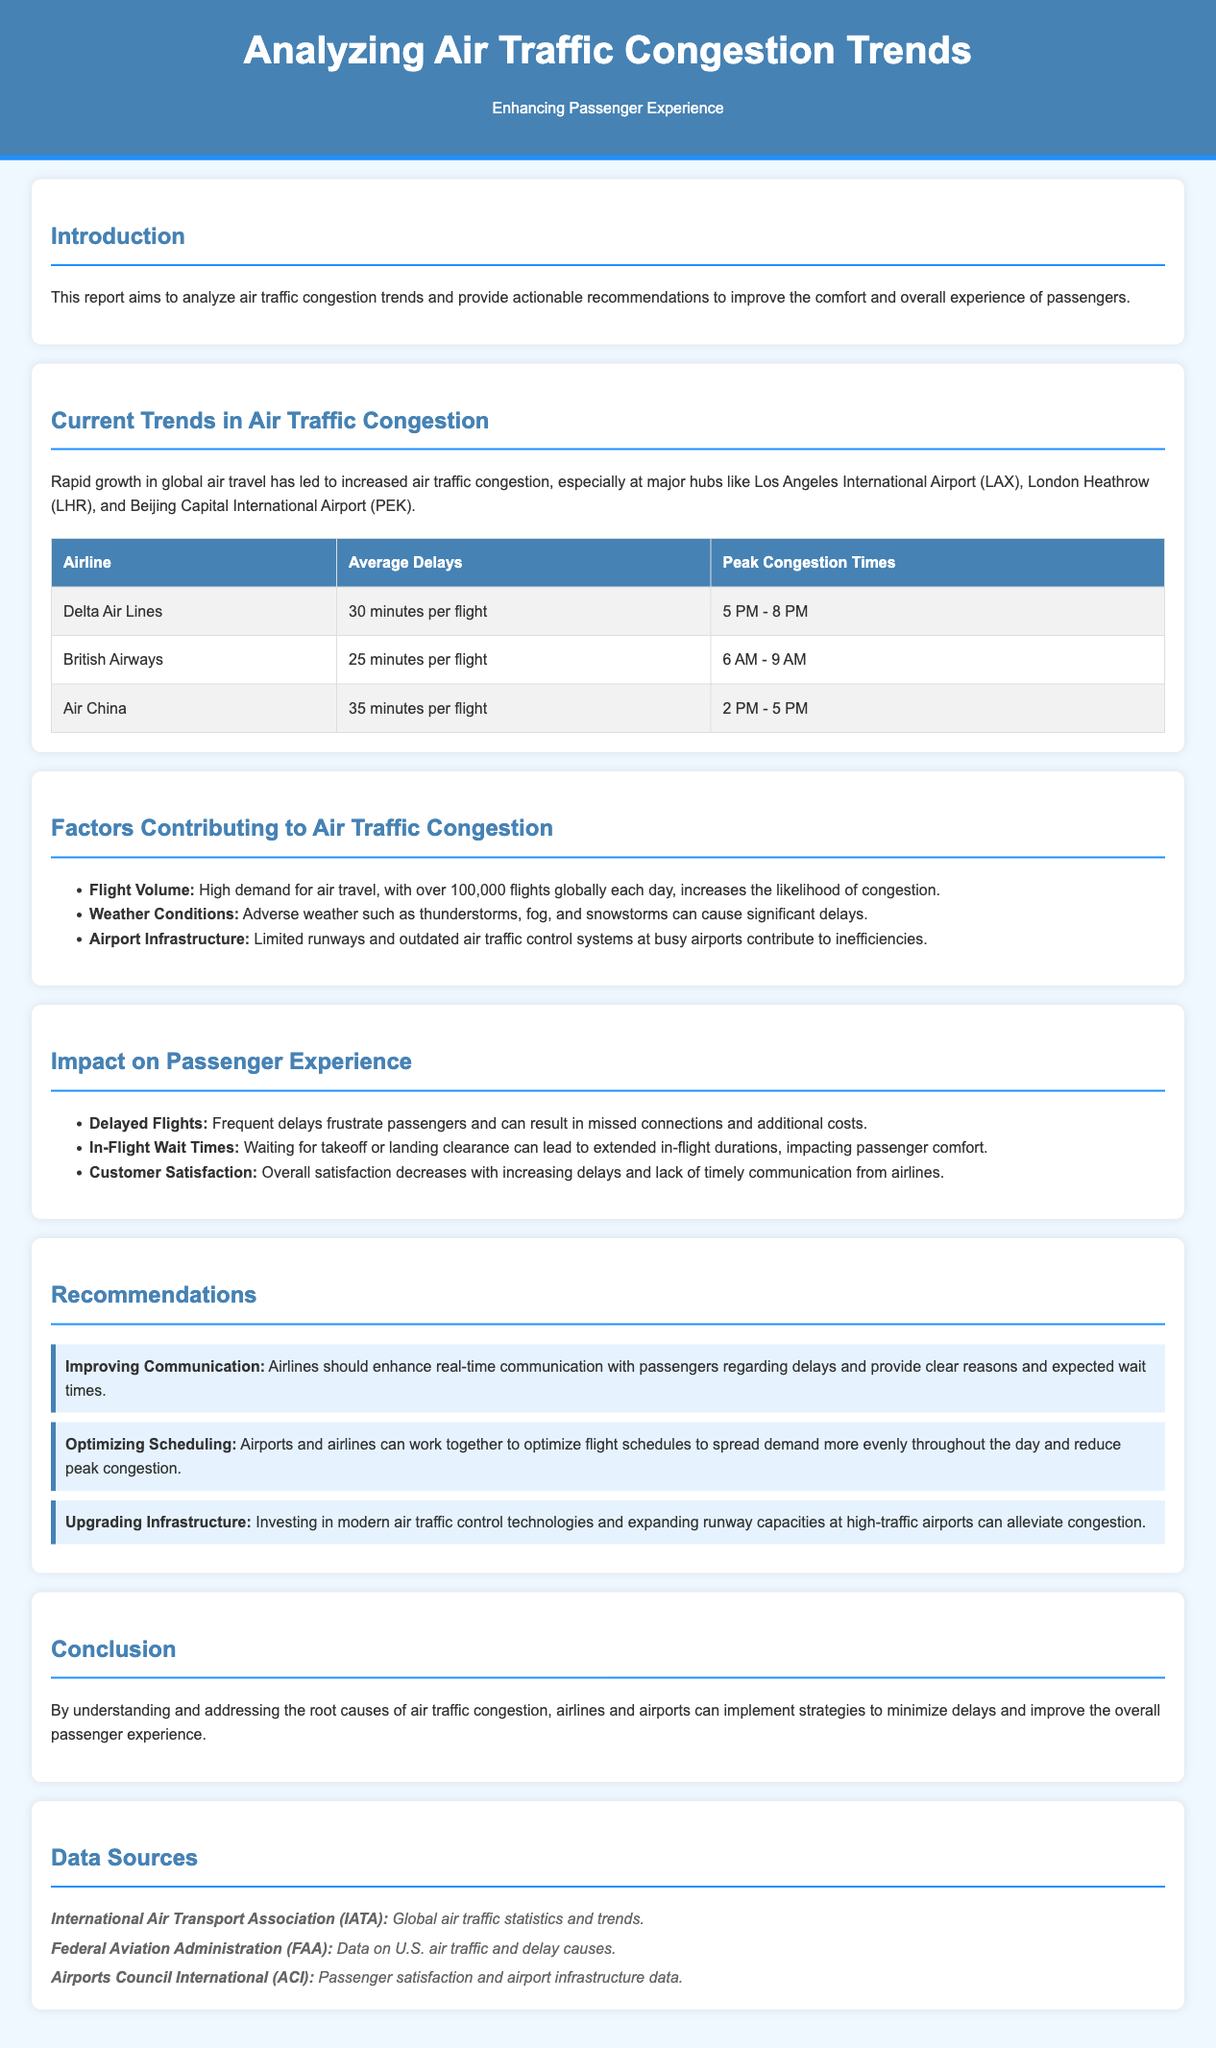What is the main focus of the report? The report aims to analyze air traffic congestion trends and provide actionable recommendations to improve the comfort and overall experience of passengers.
Answer: Analyzing air traffic congestion trends What is the average delay for Delta Air Lines? The average delay for Delta Air Lines is provided in the table under the section "Current Trends in Air Traffic Congestion."
Answer: 30 minutes per flight What time is identified as peak congestion for British Airways? The peak congestion time for British Airways is mentioned in the congestion table.
Answer: 6 AM - 9 AM Which airport has the highest average delays? The maximum average delays are indicated in the table related to each airline.
Answer: Air China What is one major factor contributing to air traffic congestion? Factors contributing to congestion are listed in a section, and one of them can be derived from that list.
Answer: Flight Volume Which recommendation addresses real-time communication with passengers? The recommendations section includes multiple suggestions, one of which specifically mentions improving communication.
Answer: Improving Communication What is a consequence of delayed flights on passengers? The impact section describes various effects of delays, including frustration and missed connections.
Answer: Frustration Which organization provides global air traffic statistics and trends? The data sources section lists organizations along with their roles in air traffic data gathering.
Answer: International Air Transport Association (IATA) 